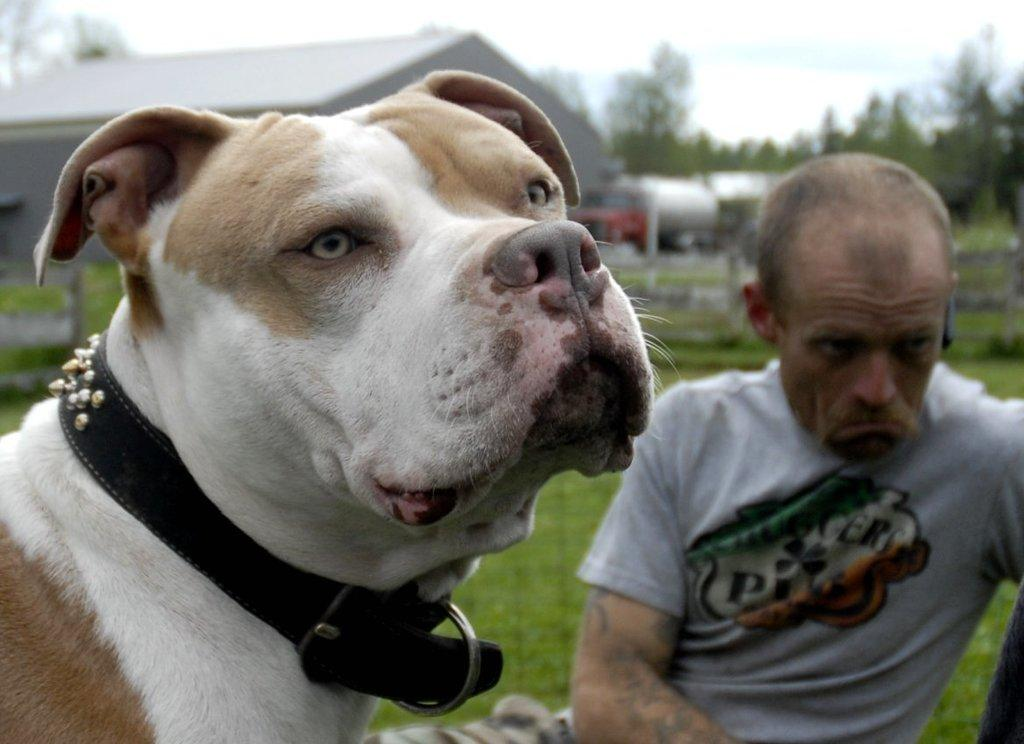What animal is located on the left side of the image? There is a dog on the left side of the image. What human figure is present on the right side of the image? There is a man on the right side of the image. What type of clothing is the man wearing? The man is wearing a T-shirt. What structures can be seen in the background of the image? There is a house and trees in the background of the image. What type of rabbit can be seen jumping over the organization in the image? There is no rabbit or organization present in the image; it features a dog and a man. How many giraffes are visible in the image? There are no giraffes present in the image. 